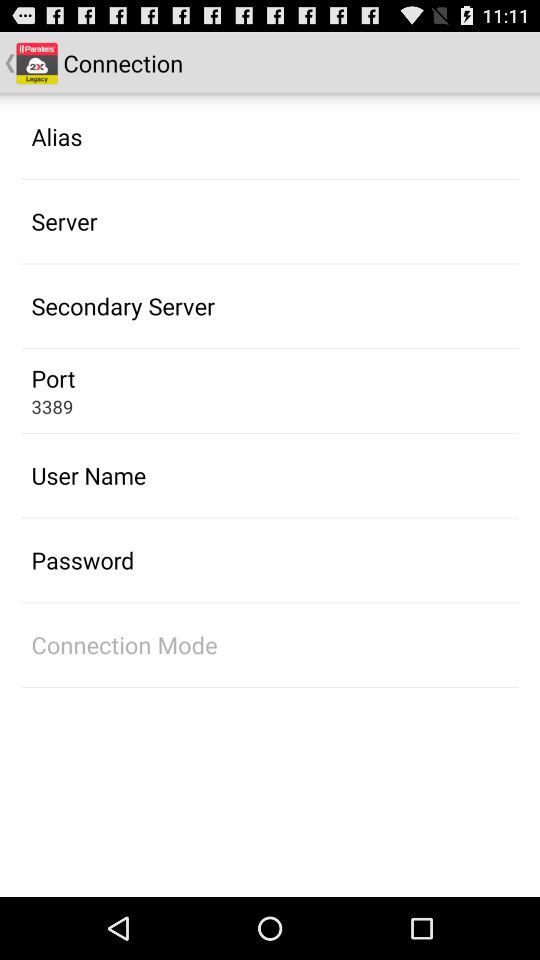What is the port number? The port number is 3389. 